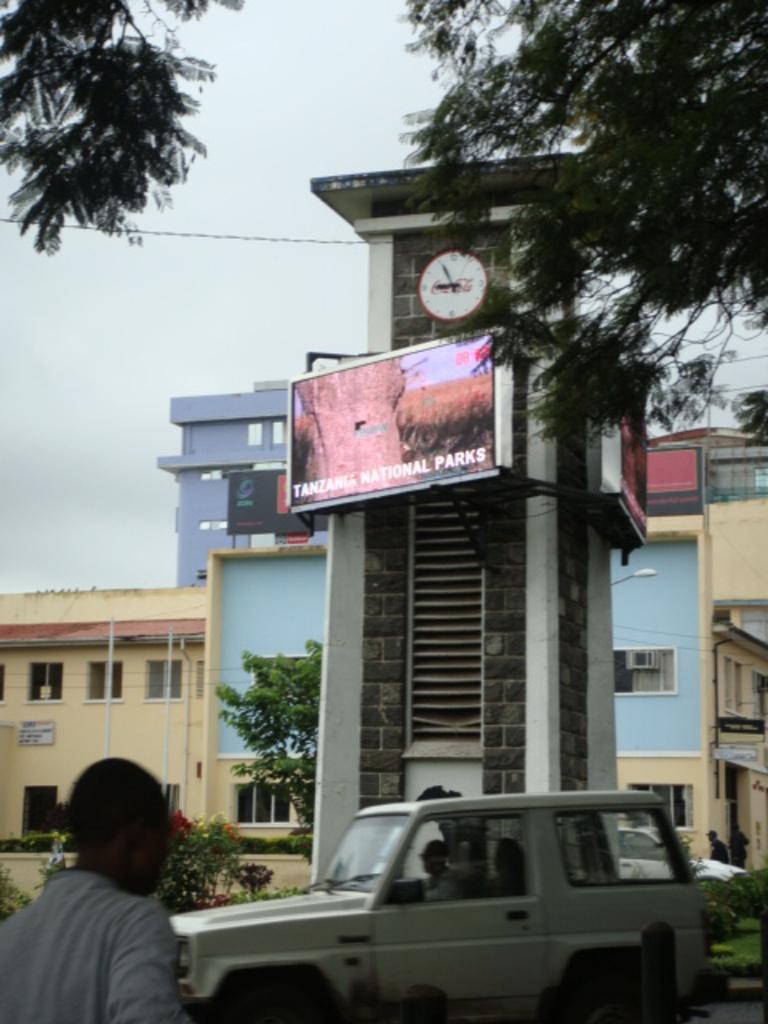Please provide a concise description of this image. On the left side, there is a person in white color T-shirt. On the right side, there is a white color vehicle on the road. On the top left, there are branches of a tree. On the top right, there are branches of a tree. In the background, there are hoardings and a clock attached to a tower, there are trees, buildings and plants on the ground and there are clouds in the sky. 